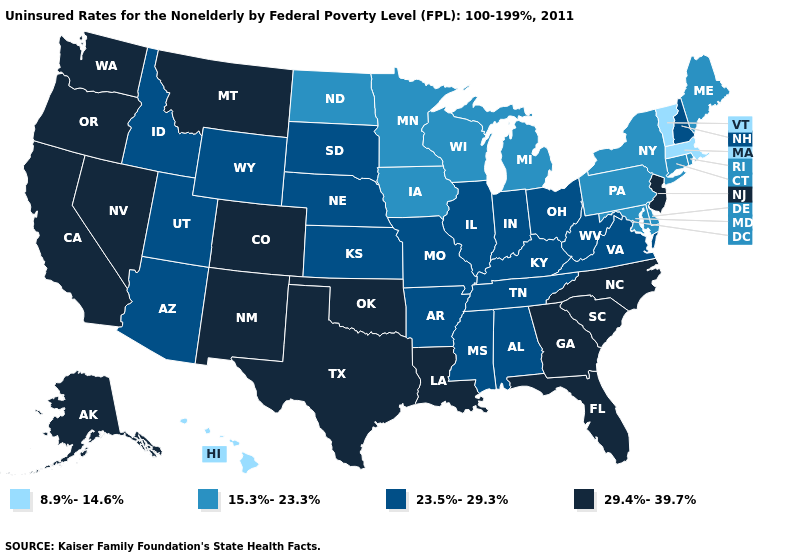What is the value of Hawaii?
Answer briefly. 8.9%-14.6%. What is the lowest value in the West?
Write a very short answer. 8.9%-14.6%. Does Nebraska have a lower value than New York?
Short answer required. No. Name the states that have a value in the range 23.5%-29.3%?
Give a very brief answer. Alabama, Arizona, Arkansas, Idaho, Illinois, Indiana, Kansas, Kentucky, Mississippi, Missouri, Nebraska, New Hampshire, Ohio, South Dakota, Tennessee, Utah, Virginia, West Virginia, Wyoming. Among the states that border Louisiana , does Arkansas have the highest value?
Quick response, please. No. What is the value of Iowa?
Answer briefly. 15.3%-23.3%. What is the value of Rhode Island?
Give a very brief answer. 15.3%-23.3%. Name the states that have a value in the range 23.5%-29.3%?
Quick response, please. Alabama, Arizona, Arkansas, Idaho, Illinois, Indiana, Kansas, Kentucky, Mississippi, Missouri, Nebraska, New Hampshire, Ohio, South Dakota, Tennessee, Utah, Virginia, West Virginia, Wyoming. Among the states that border Massachusetts , does Vermont have the lowest value?
Short answer required. Yes. What is the value of Minnesota?
Be succinct. 15.3%-23.3%. What is the value of Vermont?
Quick response, please. 8.9%-14.6%. Does Michigan have the highest value in the USA?
Quick response, please. No. What is the lowest value in the West?
Concise answer only. 8.9%-14.6%. How many symbols are there in the legend?
Short answer required. 4. 